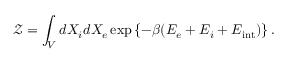<formula> <loc_0><loc_0><loc_500><loc_500>\mathcal { Z } = \int _ { V } d X _ { i } d X _ { e } \exp \left \{ - \beta ( E _ { e } + E _ { i } + E _ { i n t } ) \right \} .</formula> 